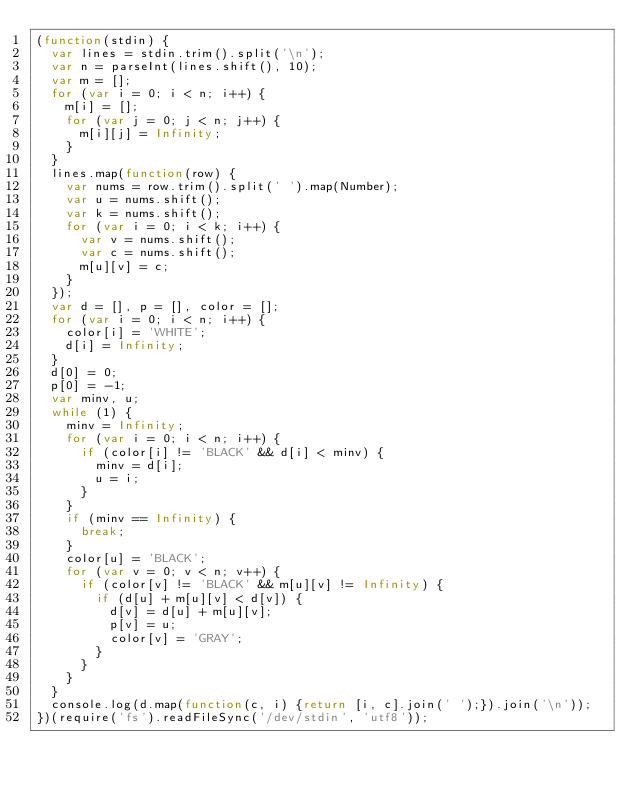Convert code to text. <code><loc_0><loc_0><loc_500><loc_500><_JavaScript_>(function(stdin) {
  var lines = stdin.trim().split('\n');
  var n = parseInt(lines.shift(), 10);
  var m = [];
  for (var i = 0; i < n; i++) {
    m[i] = [];
    for (var j = 0; j < n; j++) {
      m[i][j] = Infinity;
    }
  }
  lines.map(function(row) {
    var nums = row.trim().split(' ').map(Number);
    var u = nums.shift();
    var k = nums.shift();
    for (var i = 0; i < k; i++) {
      var v = nums.shift();
      var c = nums.shift();
      m[u][v] = c;
    }
  });
  var d = [], p = [], color = [];
  for (var i = 0; i < n; i++) {
    color[i] = 'WHITE';
    d[i] = Infinity;
  }
  d[0] = 0;
  p[0] = -1;
  var minv, u;
  while (1) {
    minv = Infinity;
    for (var i = 0; i < n; i++) {
      if (color[i] != 'BLACK' && d[i] < minv) {
        minv = d[i];
        u = i;
      }
    }
    if (minv == Infinity) {
      break;
    }
    color[u] = 'BLACK';
    for (var v = 0; v < n; v++) {
      if (color[v] != 'BLACK' && m[u][v] != Infinity) {
        if (d[u] + m[u][v] < d[v]) {
          d[v] = d[u] + m[u][v];
          p[v] = u;
          color[v] = 'GRAY';
        }
      }
    }
  }
  console.log(d.map(function(c, i) {return [i, c].join(' ');}).join('\n'));
})(require('fs').readFileSync('/dev/stdin', 'utf8'));</code> 